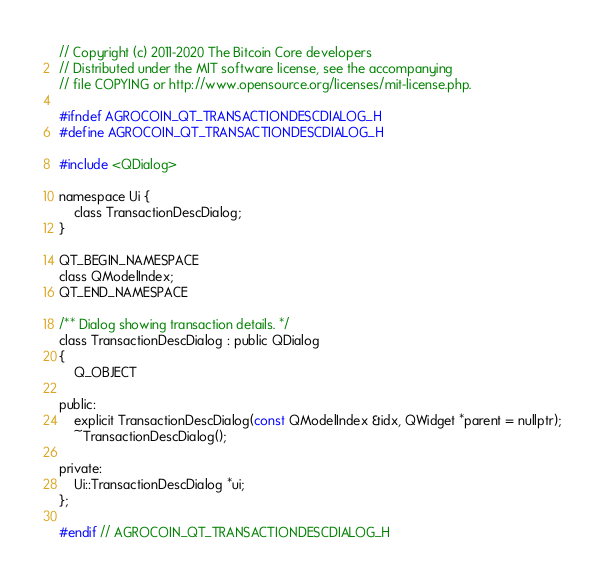Convert code to text. <code><loc_0><loc_0><loc_500><loc_500><_C_>// Copyright (c) 2011-2020 The Bitcoin Core developers
// Distributed under the MIT software license, see the accompanying
// file COPYING or http://www.opensource.org/licenses/mit-license.php.

#ifndef AGROCOIN_QT_TRANSACTIONDESCDIALOG_H
#define AGROCOIN_QT_TRANSACTIONDESCDIALOG_H

#include <QDialog>

namespace Ui {
    class TransactionDescDialog;
}

QT_BEGIN_NAMESPACE
class QModelIndex;
QT_END_NAMESPACE

/** Dialog showing transaction details. */
class TransactionDescDialog : public QDialog
{
    Q_OBJECT

public:
    explicit TransactionDescDialog(const QModelIndex &idx, QWidget *parent = nullptr);
    ~TransactionDescDialog();

private:
    Ui::TransactionDescDialog *ui;
};

#endif // AGROCOIN_QT_TRANSACTIONDESCDIALOG_H
</code> 